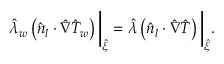Convert formula to latex. <formula><loc_0><loc_0><loc_500><loc_500>\hat { \lambda } _ { w } \left ( \hat { n } _ { l } \cdot \hat { \nabla } \hat { T } _ { w } \right ) \left | _ { \hat { \xi } } = \hat { \lambda } \left ( \hat { n } _ { l } \cdot \hat { \nabla } \hat { T } \right ) \right | _ { \hat { \xi } } .</formula> 